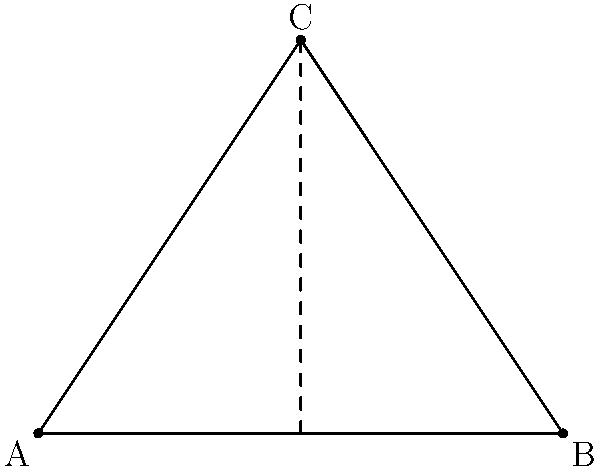In a preschool activity designed to introduce simple geometry concepts, children are given a dotted template to trace and draw lines forming a triangle. If the dotted lines form a right angle at point A, what type of triangle will the children create when they connect all three points? To determine the type of triangle, let's analyze the given information and the resulting shape:

1. The children are given a dotted template to trace and draw lines.
2. The dotted lines form a right angle at point A.
3. When all three points are connected, a triangle is formed.

Now, let's consider the properties of the triangle:

1. We know that one angle (at point A) is a right angle (90 degrees).
2. In any triangle, the sum of all interior angles must equal 180 degrees.
3. The remaining two angles must sum to 90 degrees (180 - 90 = 90).
4. When one angle in a triangle is 90 degrees and the other two angles are acute (less than 90 degrees), it is called a right triangle.

Therefore, when the children connect all three points following the dotted template, they will create a right triangle.

This activity helps preschoolers develop fine motor skills through tracing and drawing while introducing them to basic geometric shapes and angles.
Answer: Right triangle 